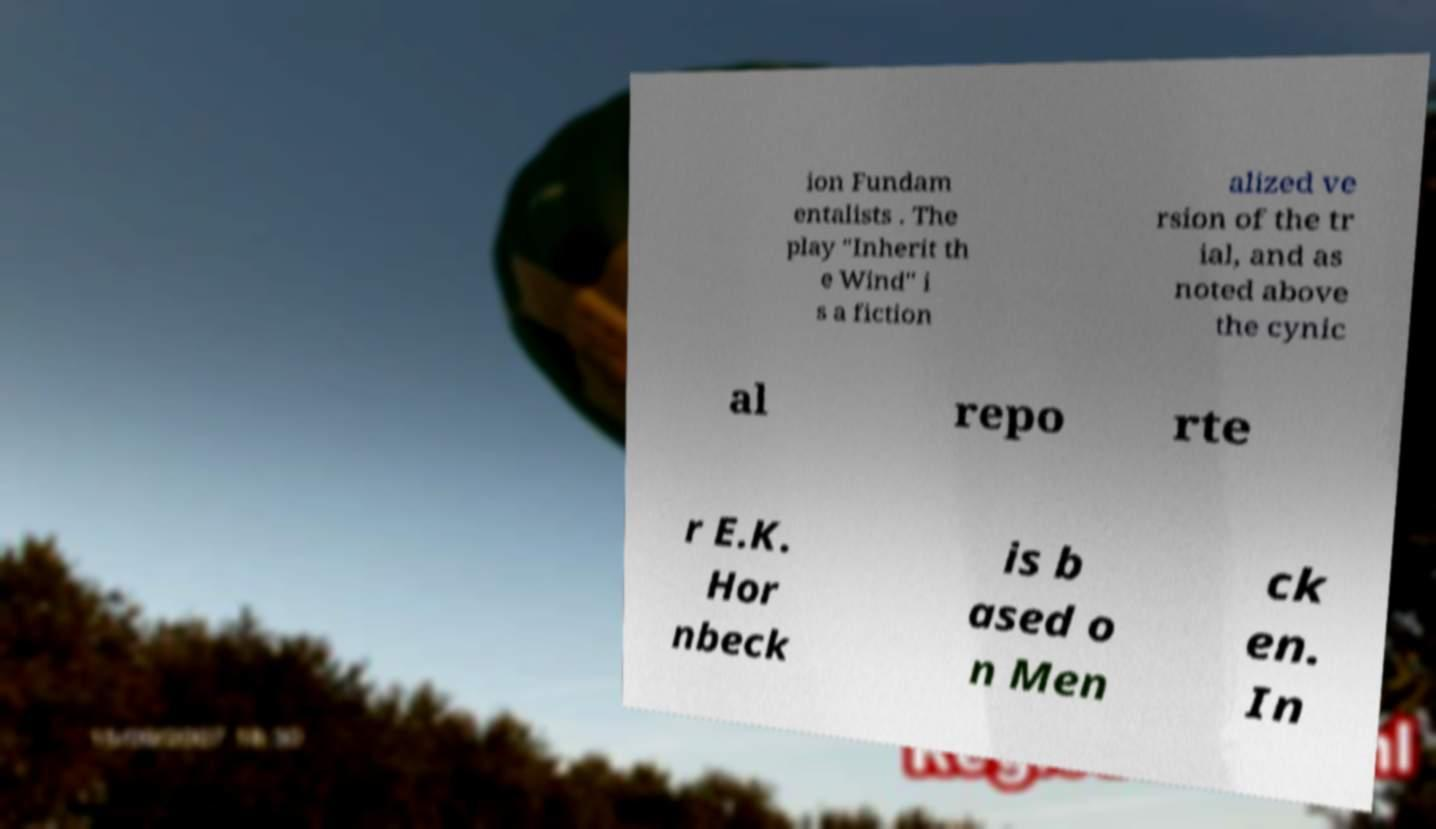Please identify and transcribe the text found in this image. ion Fundam entalists . The play "Inherit th e Wind" i s a fiction alized ve rsion of the tr ial, and as noted above the cynic al repo rte r E.K. Hor nbeck is b ased o n Men ck en. In 